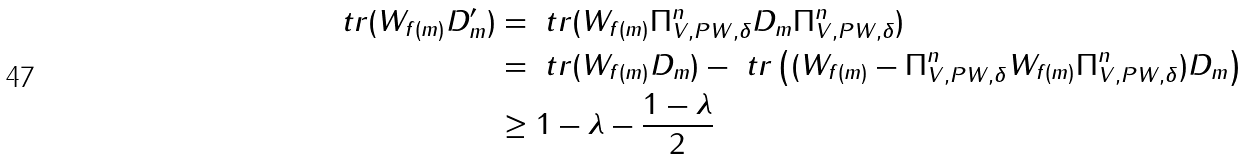<formula> <loc_0><loc_0><loc_500><loc_500>\ t r ( W _ { f ( m ) } D _ { m } ^ { \prime } ) & = \ t r ( W _ { f ( m ) } \Pi ^ { n } _ { V , P W , \delta } D _ { m } \Pi ^ { n } _ { V , P W , \delta } ) \\ & = \ t r ( W _ { f ( m ) } D _ { m } ) - \ t r \left ( ( W _ { f ( m ) } - \Pi ^ { n } _ { V , P W , \delta } W _ { f ( m ) } \Pi ^ { n } _ { V , P W , \delta } ) D _ { m } \right ) \\ & \geq 1 - \lambda - \frac { 1 - \lambda } { 2 }</formula> 